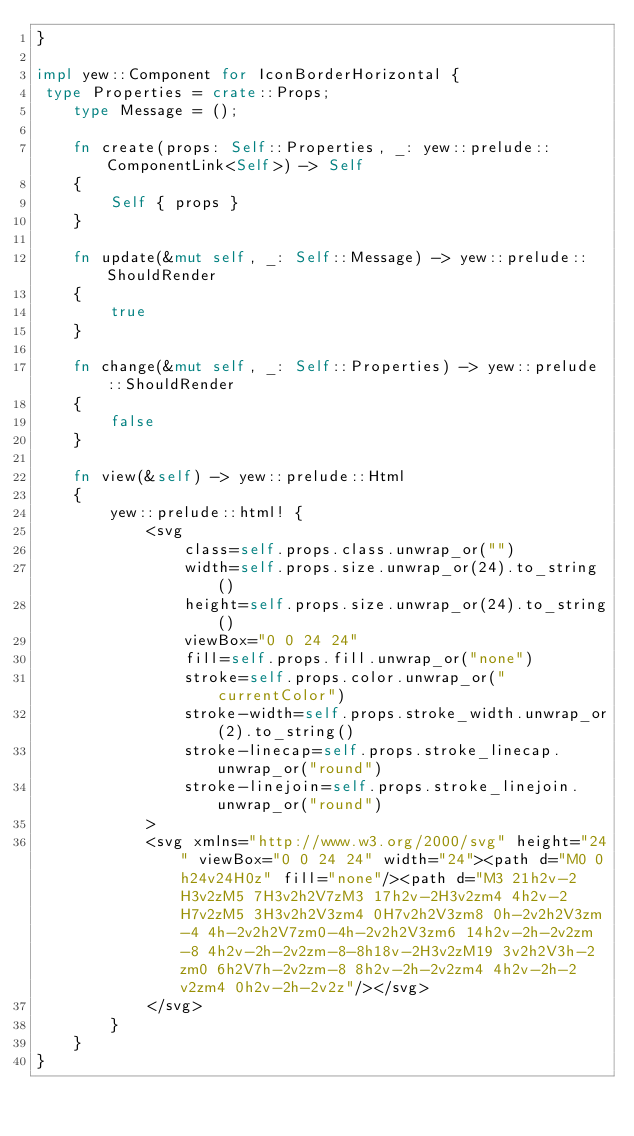Convert code to text. <code><loc_0><loc_0><loc_500><loc_500><_Rust_>}

impl yew::Component for IconBorderHorizontal {
 type Properties = crate::Props;
    type Message = ();

    fn create(props: Self::Properties, _: yew::prelude::ComponentLink<Self>) -> Self
    {
        Self { props }
    }

    fn update(&mut self, _: Self::Message) -> yew::prelude::ShouldRender
    {
        true
    }

    fn change(&mut self, _: Self::Properties) -> yew::prelude::ShouldRender
    {
        false
    }

    fn view(&self) -> yew::prelude::Html
    {
        yew::prelude::html! {
            <svg
                class=self.props.class.unwrap_or("")
                width=self.props.size.unwrap_or(24).to_string()
                height=self.props.size.unwrap_or(24).to_string()
                viewBox="0 0 24 24"
                fill=self.props.fill.unwrap_or("none")
                stroke=self.props.color.unwrap_or("currentColor")
                stroke-width=self.props.stroke_width.unwrap_or(2).to_string()
                stroke-linecap=self.props.stroke_linecap.unwrap_or("round")
                stroke-linejoin=self.props.stroke_linejoin.unwrap_or("round")
            >
            <svg xmlns="http://www.w3.org/2000/svg" height="24" viewBox="0 0 24 24" width="24"><path d="M0 0h24v24H0z" fill="none"/><path d="M3 21h2v-2H3v2zM5 7H3v2h2V7zM3 17h2v-2H3v2zm4 4h2v-2H7v2zM5 3H3v2h2V3zm4 0H7v2h2V3zm8 0h-2v2h2V3zm-4 4h-2v2h2V7zm0-4h-2v2h2V3zm6 14h2v-2h-2v2zm-8 4h2v-2h-2v2zm-8-8h18v-2H3v2zM19 3v2h2V3h-2zm0 6h2V7h-2v2zm-8 8h2v-2h-2v2zm4 4h2v-2h-2v2zm4 0h2v-2h-2v2z"/></svg>
            </svg>
        }
    }
}


</code> 